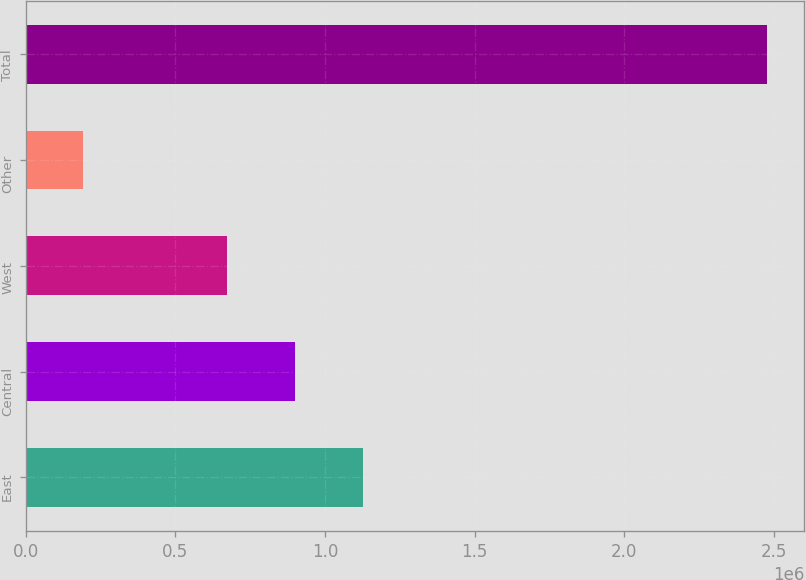<chart> <loc_0><loc_0><loc_500><loc_500><bar_chart><fcel>East<fcel>Central<fcel>West<fcel>Other<fcel>Total<nl><fcel>1.1286e+06<fcel>900061<fcel>671524<fcel>192379<fcel>2.47775e+06<nl></chart> 